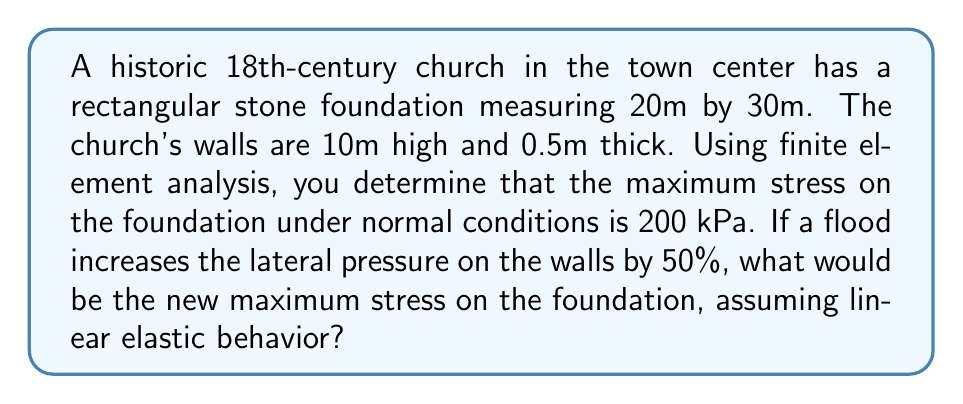Give your solution to this math problem. To solve this problem, we'll use the principles of finite element analysis and linear elasticity. Let's break it down step-by-step:

1) First, we need to understand the initial conditions:
   - Foundation dimensions: 20m x 30m
   - Wall height: 10m
   - Wall thickness: 0.5m
   - Initial maximum stress: 200 kPa

2) In linear elastic behavior, stress is directly proportional to the applied load. This means that if the load increases by a certain percentage, the stress will increase by the same percentage.

3) The flood increases the lateral pressure on the walls by 50%. This additional pressure will transfer to the foundation, increasing the stress.

4) To calculate the new maximum stress, we can use the following equation:

   $$ \text{New Stress} = \text{Initial Stress} \times (1 + \text{Pressure Increase}) $$

5) Plugging in our values:

   $$ \text{New Stress} = 200 \text{ kPa} \times (1 + 0.50) $$

6) Simplifying:

   $$ \text{New Stress} = 200 \text{ kPa} \times 1.50 = 300 \text{ kPa} $$

Therefore, the new maximum stress on the foundation after the flood would be 300 kPa.
Answer: 300 kPa 